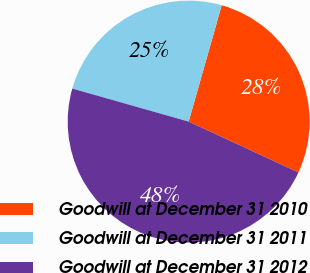Convert chart to OTSL. <chart><loc_0><loc_0><loc_500><loc_500><pie_chart><fcel>Goodwill at December 31 2010<fcel>Goodwill at December 31 2011<fcel>Goodwill at December 31 2012<nl><fcel>27.5%<fcel>25.0%<fcel>47.5%<nl></chart> 